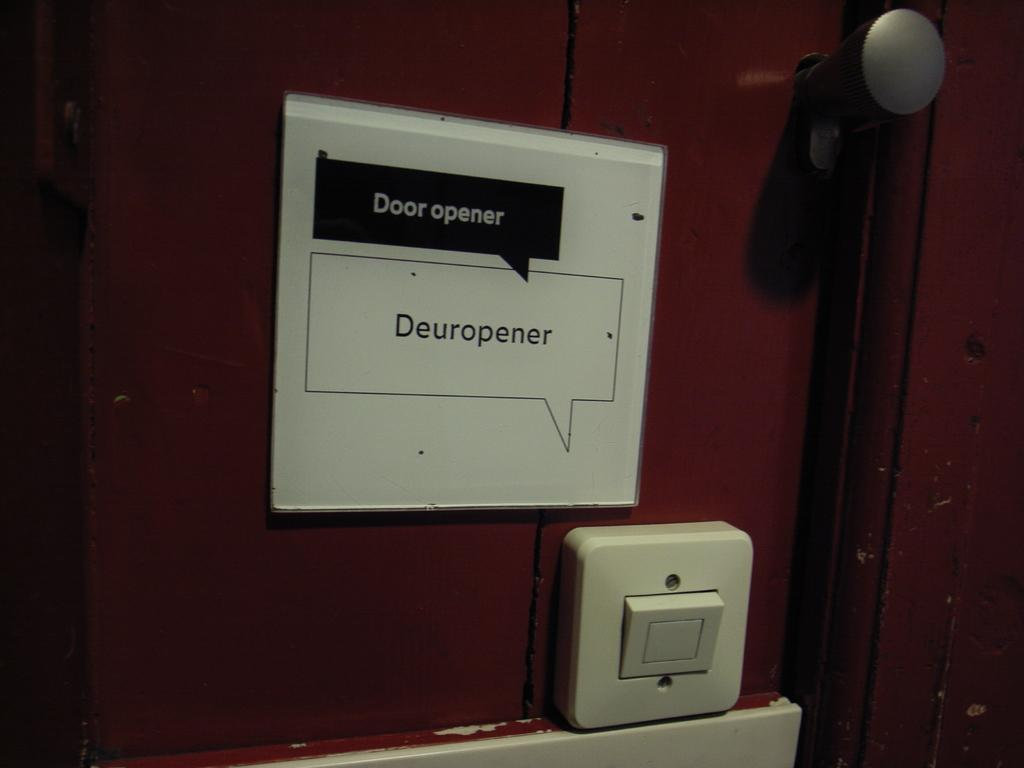<image>
Present a compact description of the photo's key features. A door has a sign that says door opener above a button. 